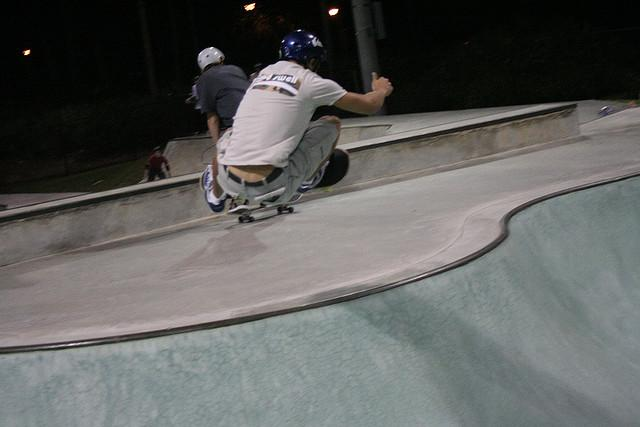World skate is the head controller of which game? skateboarding 